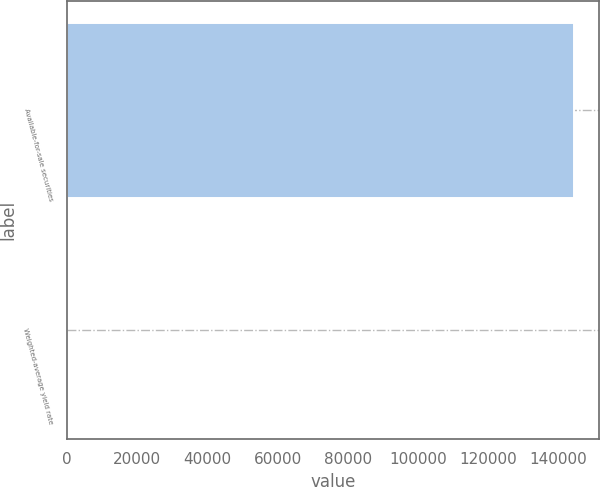Convert chart to OTSL. <chart><loc_0><loc_0><loc_500><loc_500><bar_chart><fcel>Available-for-sale securities<fcel>Weighted-average yield rate<nl><fcel>144328<fcel>0.86<nl></chart> 